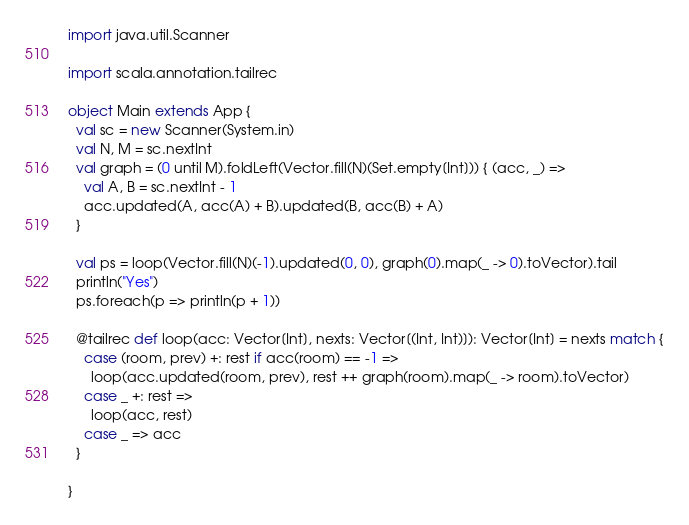Convert code to text. <code><loc_0><loc_0><loc_500><loc_500><_Scala_>import java.util.Scanner

import scala.annotation.tailrec

object Main extends App {
  val sc = new Scanner(System.in)
  val N, M = sc.nextInt
  val graph = (0 until M).foldLeft(Vector.fill(N)(Set.empty[Int])) { (acc, _) =>
    val A, B = sc.nextInt - 1
    acc.updated(A, acc(A) + B).updated(B, acc(B) + A)
  }

  val ps = loop(Vector.fill(N)(-1).updated(0, 0), graph(0).map(_ -> 0).toVector).tail
  println("Yes")
  ps.foreach(p => println(p + 1))

  @tailrec def loop(acc: Vector[Int], nexts: Vector[(Int, Int)]): Vector[Int] = nexts match {
    case (room, prev) +: rest if acc(room) == -1 =>
      loop(acc.updated(room, prev), rest ++ graph(room).map(_ -> room).toVector)
    case _ +: rest =>
      loop(acc, rest)
    case _ => acc
  }

}

</code> 